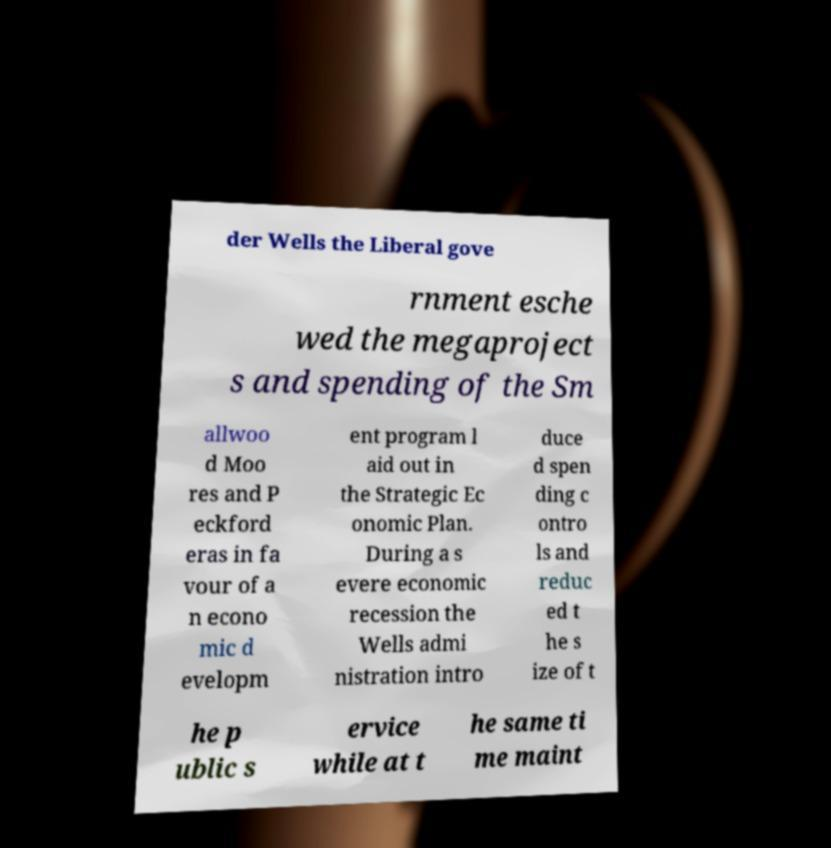I need the written content from this picture converted into text. Can you do that? der Wells the Liberal gove rnment esche wed the megaproject s and spending of the Sm allwoo d Moo res and P eckford eras in fa vour of a n econo mic d evelopm ent program l aid out in the Strategic Ec onomic Plan. During a s evere economic recession the Wells admi nistration intro duce d spen ding c ontro ls and reduc ed t he s ize of t he p ublic s ervice while at t he same ti me maint 